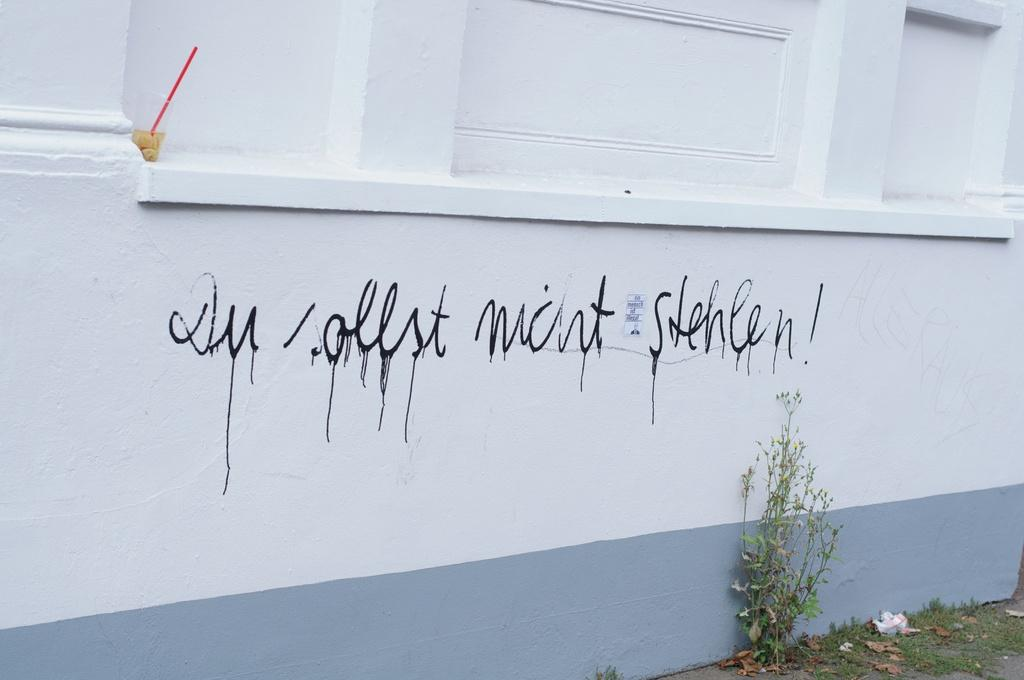What type of structure is present in the image? There is a building in the image. What type of vegetation can be seen in the image? There is a plant and grass in the image. What is the tendency of the flower to grow in the image? There is no flower present in the image, so we cannot determine its tendency to grow. 